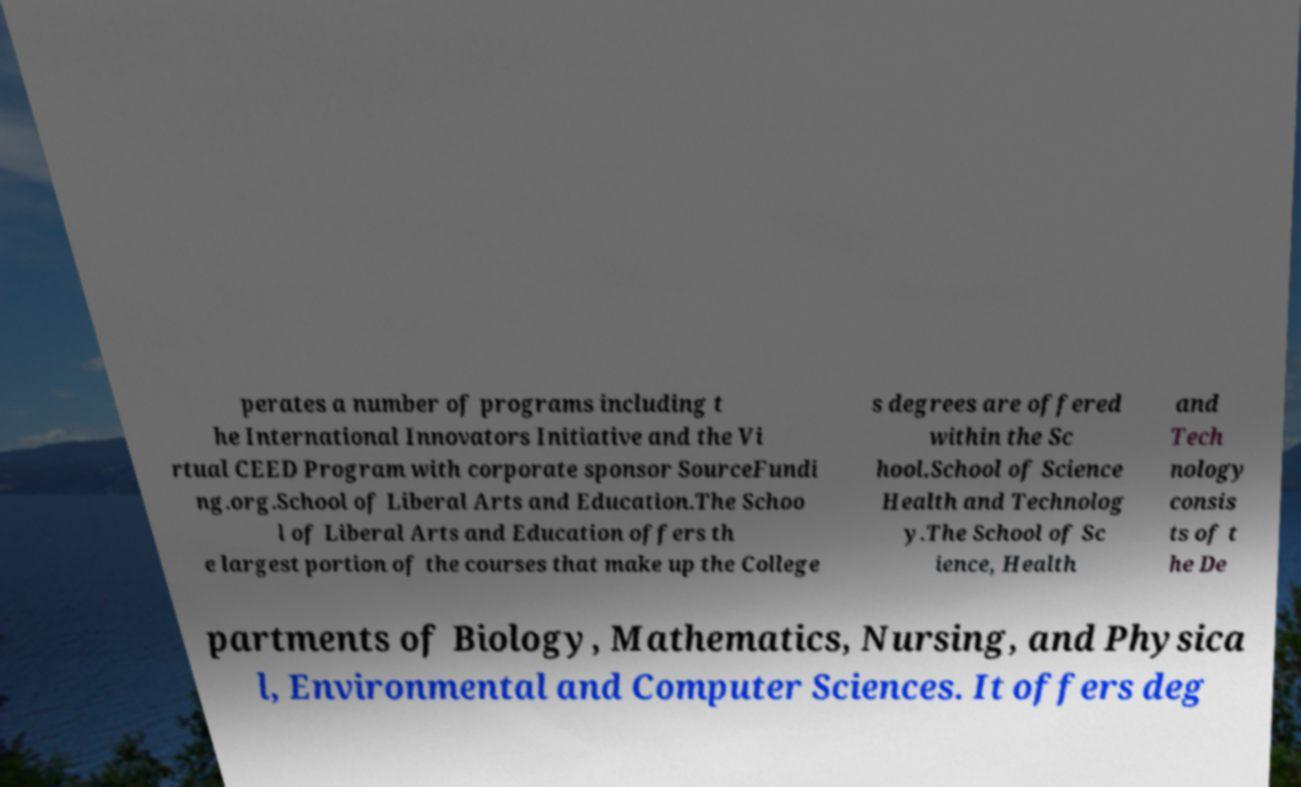Please identify and transcribe the text found in this image. perates a number of programs including t he International Innovators Initiative and the Vi rtual CEED Program with corporate sponsor SourceFundi ng.org.School of Liberal Arts and Education.The Schoo l of Liberal Arts and Education offers th e largest portion of the courses that make up the College s degrees are offered within the Sc hool.School of Science Health and Technolog y.The School of Sc ience, Health and Tech nology consis ts of t he De partments of Biology, Mathematics, Nursing, and Physica l, Environmental and Computer Sciences. It offers deg 